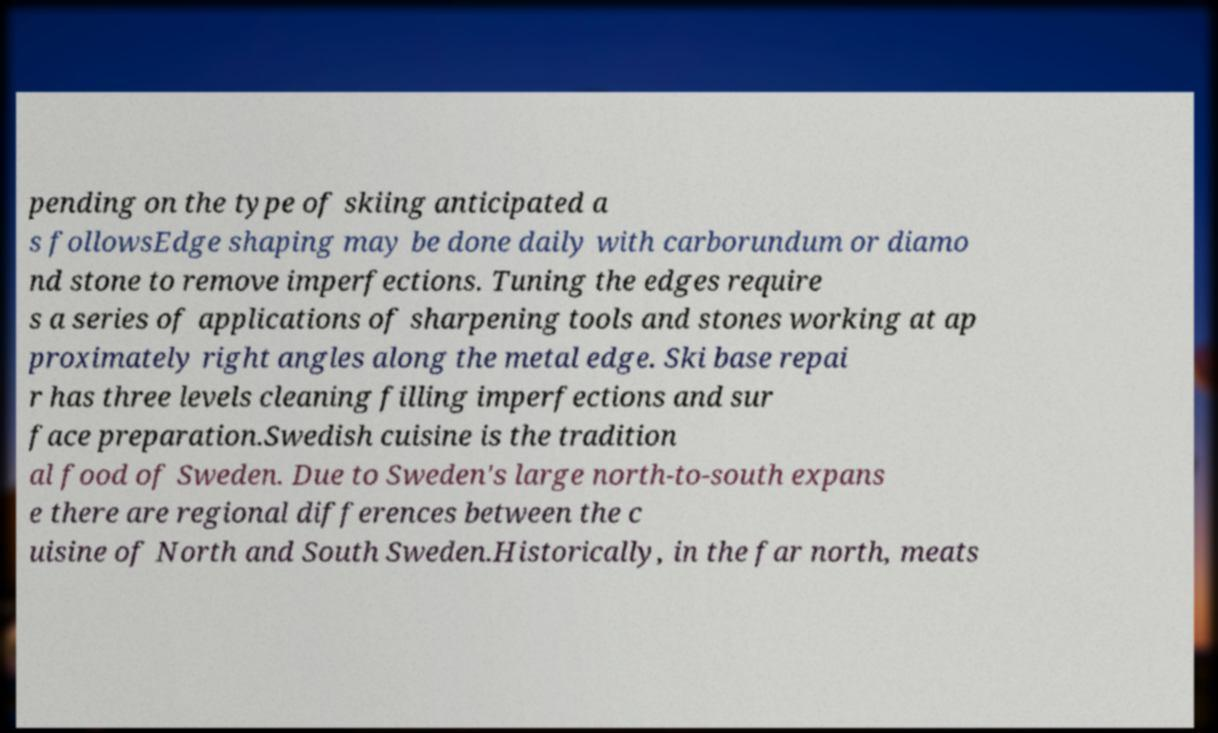Could you extract and type out the text from this image? pending on the type of skiing anticipated a s followsEdge shaping may be done daily with carborundum or diamo nd stone to remove imperfections. Tuning the edges require s a series of applications of sharpening tools and stones working at ap proximately right angles along the metal edge. Ski base repai r has three levels cleaning filling imperfections and sur face preparation.Swedish cuisine is the tradition al food of Sweden. Due to Sweden's large north-to-south expans e there are regional differences between the c uisine of North and South Sweden.Historically, in the far north, meats 